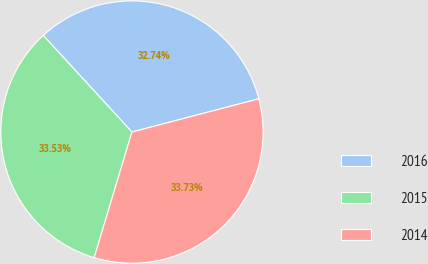<chart> <loc_0><loc_0><loc_500><loc_500><pie_chart><fcel>2016<fcel>2015<fcel>2014<nl><fcel>32.74%<fcel>33.53%<fcel>33.73%<nl></chart> 